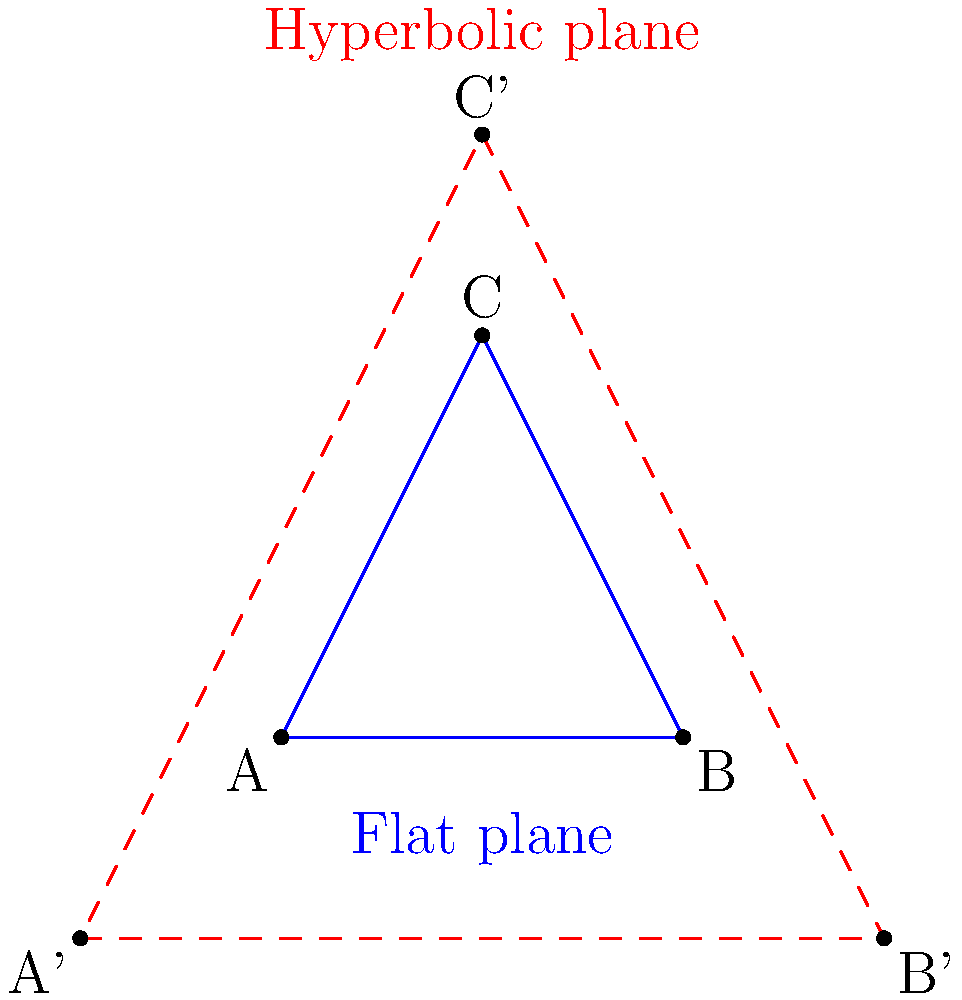In your role as a hospice administrator, you're organizing a training session on spatial awareness for your staff. To illustrate the concept of non-Euclidean geometry, you present two triangles: one on a flat plane (blue) and one on a hyperbolic plane (red, dashed). If the sum of the interior angles of the triangle on the flat plane is 180°, how does the sum of the interior angles of the triangle on the hyperbolic plane compare? To understand the difference between the sum of angles in triangles on flat and hyperbolic planes, let's follow these steps:

1. Flat (Euclidean) plane:
   - In Euclidean geometry, the sum of interior angles of a triangle is always 180°.
   - This is represented by the blue triangle in the diagram.

2. Hyperbolic plane:
   - In hyperbolic geometry, the rules are different.
   - The sum of the interior angles of a triangle is always less than 180°.

3. Key properties of hyperbolic triangles:
   - As the size of a hyperbolic triangle increases, the sum of its angles decreases.
   - The deficit between the angle sum and 180° is proportional to the area of the triangle.

4. Comparison:
   - The red, dashed triangle in the diagram represents a hyperbolic triangle.
   - Its interior angle sum will be less than 180°.

5. Implications:
   - This difference in angle sums demonstrates that spatial relationships can vary depending on the geometry of the space.
   - In the context of hospice care, this concept can be used to illustrate how perspectives and experiences can differ based on one's "frame of reference" or life circumstances.
Answer: Less than 180° 